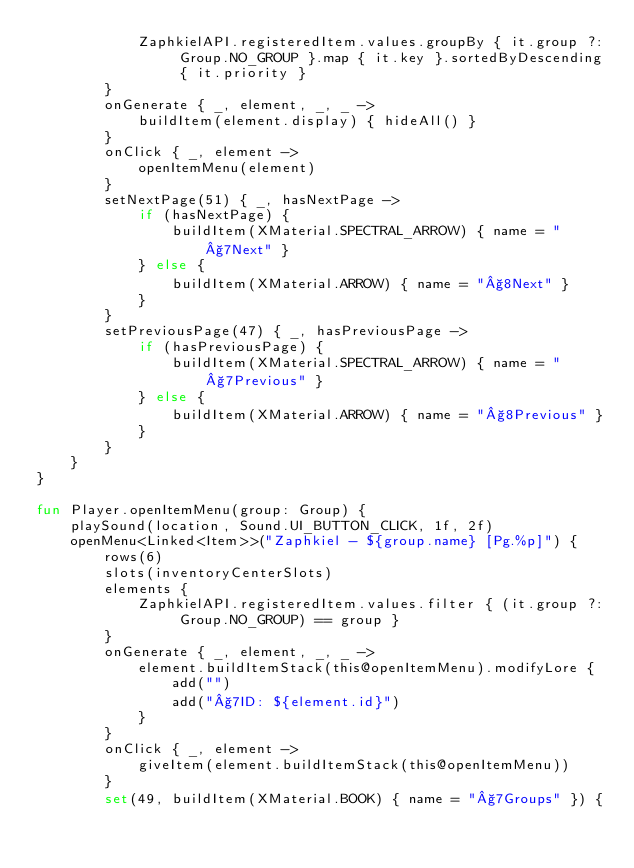Convert code to text. <code><loc_0><loc_0><loc_500><loc_500><_Kotlin_>            ZaphkielAPI.registeredItem.values.groupBy { it.group ?: Group.NO_GROUP }.map { it.key }.sortedByDescending { it.priority }
        }
        onGenerate { _, element, _, _ ->
            buildItem(element.display) { hideAll() }
        }
        onClick { _, element ->
            openItemMenu(element)
        }
        setNextPage(51) { _, hasNextPage ->
            if (hasNextPage) {
                buildItem(XMaterial.SPECTRAL_ARROW) { name = "§7Next" }
            } else {
                buildItem(XMaterial.ARROW) { name = "§8Next" }
            }
        }
        setPreviousPage(47) { _, hasPreviousPage ->
            if (hasPreviousPage) {
                buildItem(XMaterial.SPECTRAL_ARROW) { name = "§7Previous" }
            } else {
                buildItem(XMaterial.ARROW) { name = "§8Previous" }
            }
        }
    }
}

fun Player.openItemMenu(group: Group) {
    playSound(location, Sound.UI_BUTTON_CLICK, 1f, 2f)
    openMenu<Linked<Item>>("Zaphkiel - ${group.name} [Pg.%p]") {
        rows(6)
        slots(inventoryCenterSlots)
        elements {
            ZaphkielAPI.registeredItem.values.filter { (it.group ?: Group.NO_GROUP) == group }
        }
        onGenerate { _, element, _, _ ->
            element.buildItemStack(this@openItemMenu).modifyLore {
                add("")
                add("§7ID: ${element.id}")
            }
        }
        onClick { _, element ->
            giveItem(element.buildItemStack(this@openItemMenu))
        }
        set(49, buildItem(XMaterial.BOOK) { name = "§7Groups" }) {</code> 